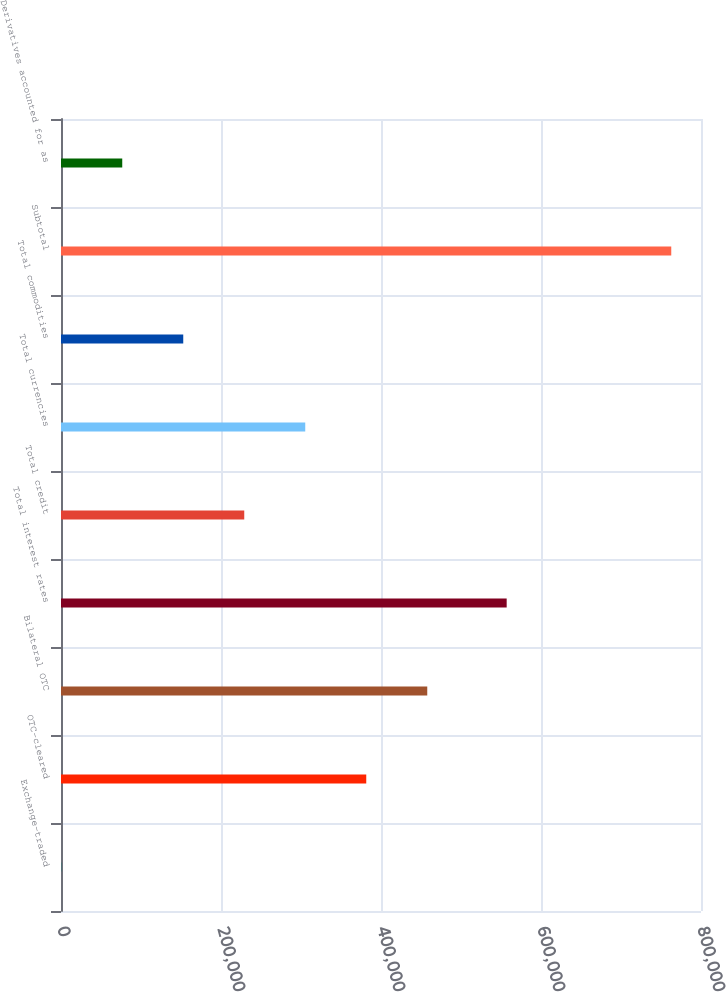Convert chart. <chart><loc_0><loc_0><loc_500><loc_500><bar_chart><fcel>Exchange-traded<fcel>OTC-cleared<fcel>Bilateral OTC<fcel>Total interest rates<fcel>Total credit<fcel>Total currencies<fcel>Total commodities<fcel>Subtotal<fcel>Derivatives accounted for as<nl><fcel>310<fcel>381566<fcel>457817<fcel>557098<fcel>229064<fcel>305315<fcel>152812<fcel>762822<fcel>76561.2<nl></chart> 